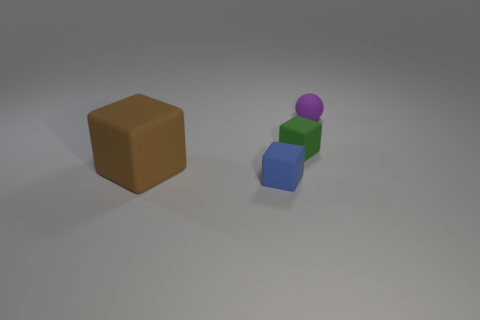Subtract all tiny blocks. How many blocks are left? 1 Subtract 1 cubes. How many cubes are left? 2 Add 2 tiny red objects. How many objects exist? 6 Subtract all green blocks. How many blocks are left? 2 Subtract 0 cyan cylinders. How many objects are left? 4 Subtract all balls. How many objects are left? 3 Subtract all red spheres. Subtract all brown cubes. How many spheres are left? 1 Subtract all green matte objects. Subtract all big yellow matte things. How many objects are left? 3 Add 4 green matte objects. How many green matte objects are left? 5 Add 2 green matte cubes. How many green matte cubes exist? 3 